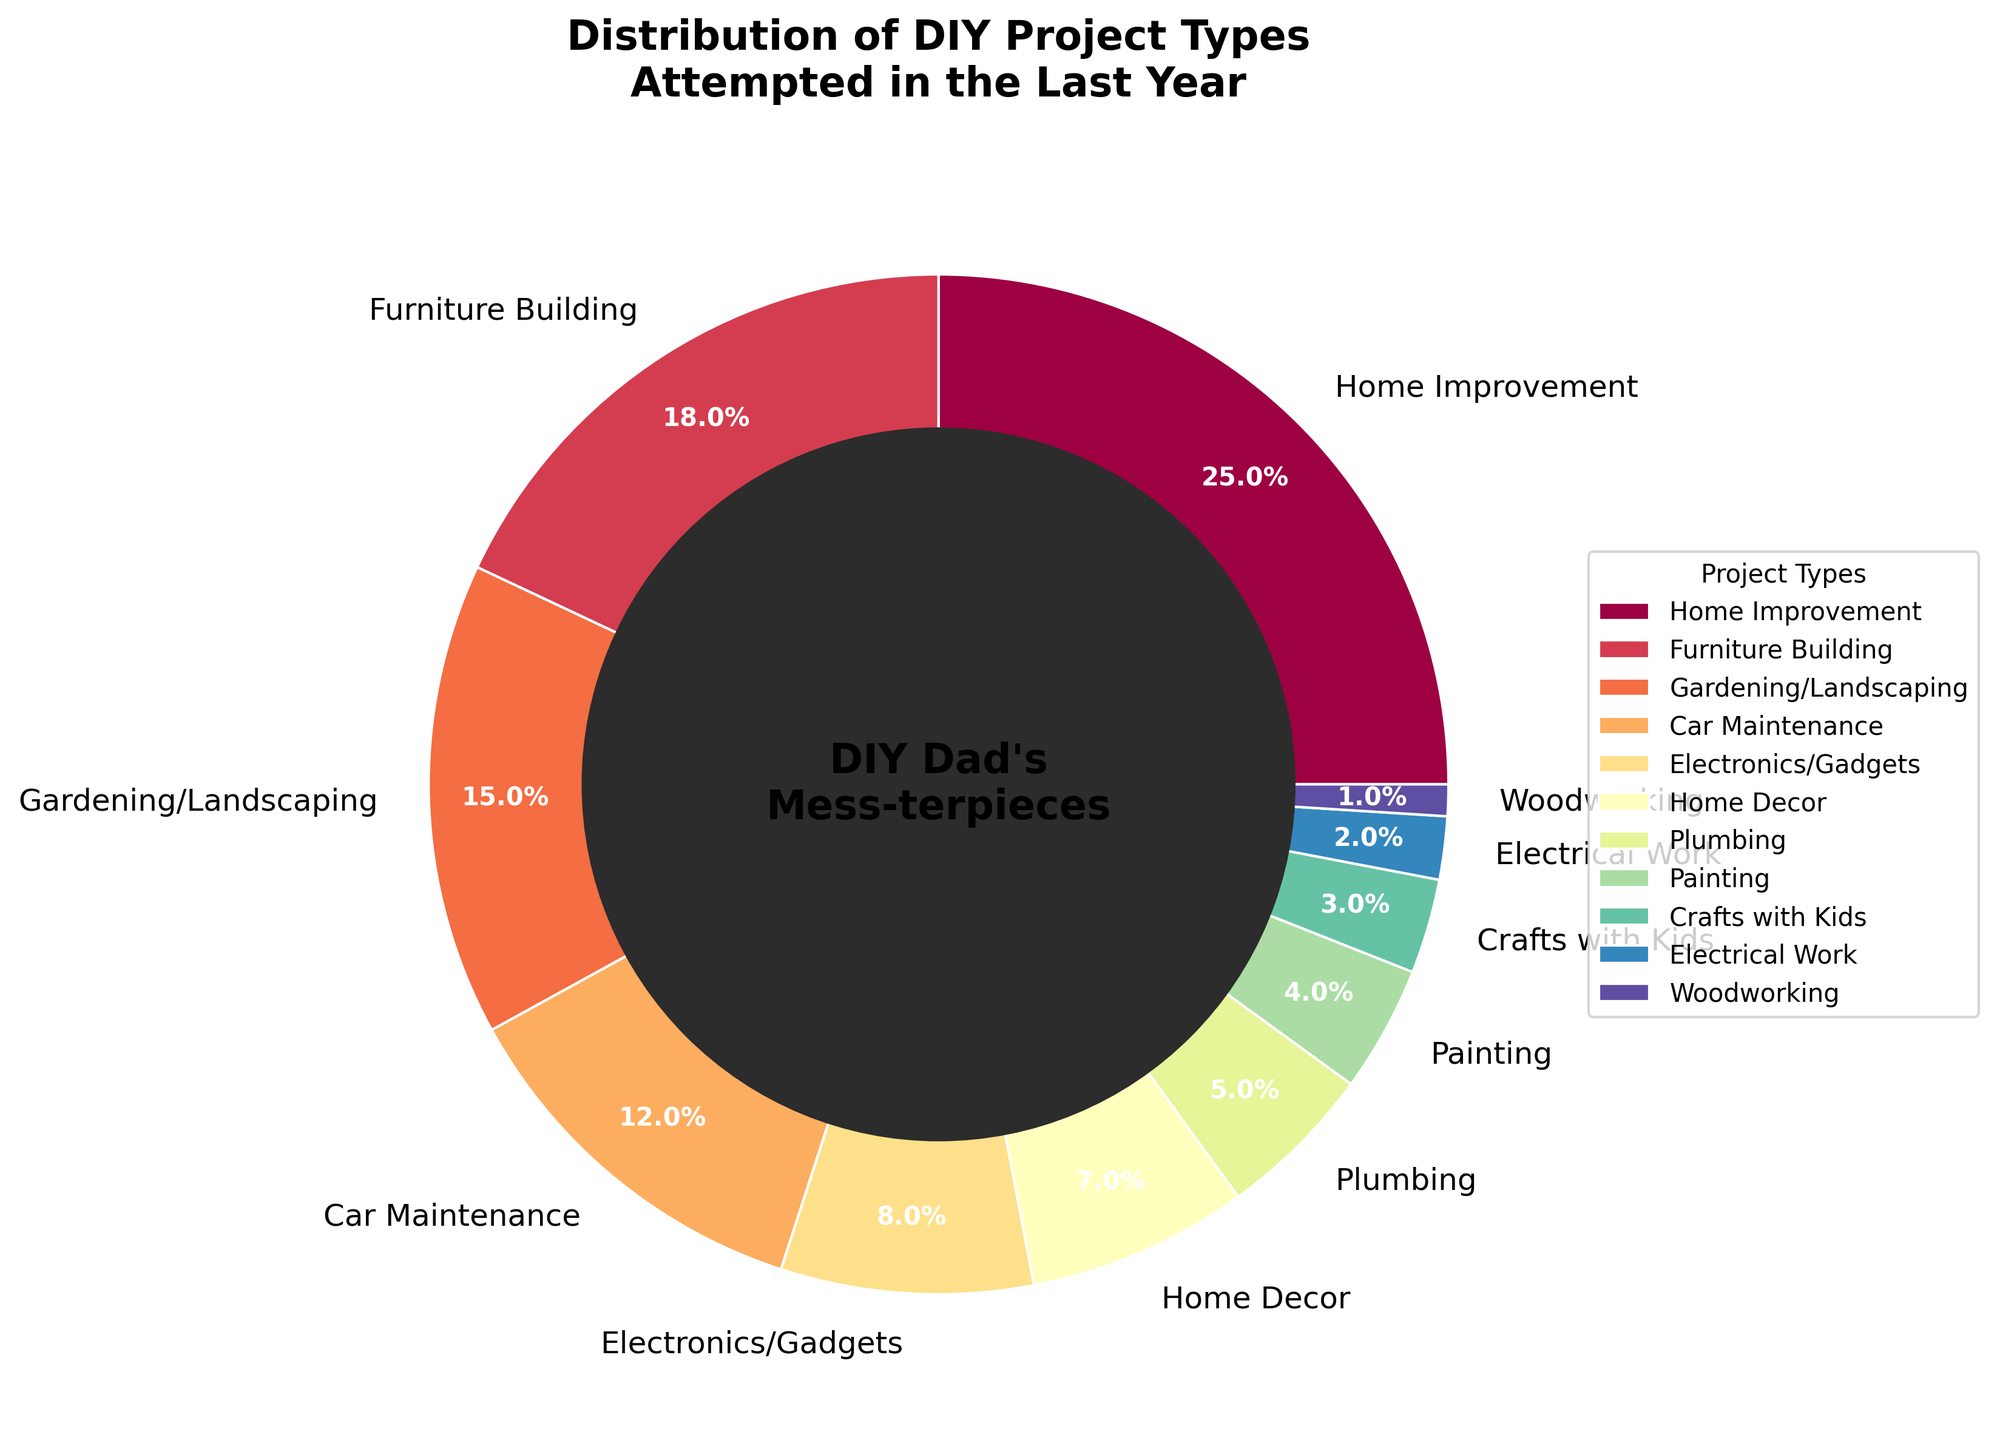Which project type had the highest percentage of attempts? Look at the segment with the largest size in the pie chart.
Answer: Home Improvement Which project type had the lowest percentage of attempts? Identify the smallest segment in the pie chart.
Answer: Woodworking What total percentage of DIY projects attempted were related to automotive and household electrical systems (Car Maintenance + Electrical Work)? Find the percentages for Car Maintenance and Electrical Work, then add them together: 12% + 2%.
Answer: 14% Are there more attempts at Gardening/Landscaping or Electronics/Gadgets? Compare the sizes of the segments for Gardening/Landscaping and Electronics/Gadgets.
Answer: Gardening/Landscaping How many project types had a percentage greater than 10%? Count the segments with percentages greater than 10%.
Answer: 4 What is the difference in percentage between Home Improvement and Plumbing projects? Subtract the percentage of Plumbing from the percentage of Home Improvement: 25% - 5%.
Answer: 20% Which project type has a percentage closest to 10%? Identify the segment with a percentage closest to 10%.
Answer: Car Maintenance What is the combined percentage of all home-related projects (Home Improvement, Home Decor, and Plumbing)? Add the percentages for Home Improvement, Home Decor, and Plumbing: 25% + 7% + 5%.
Answer: 37% Are there more attempts at Painting or Crafts with Kids? Compare the sizes of the segments for Painting and Crafts with Kids.
Answer: Painting What percentage of DIY projects were related to woodworking? Identify the percentage for Woodworking.
Answer: 1% 